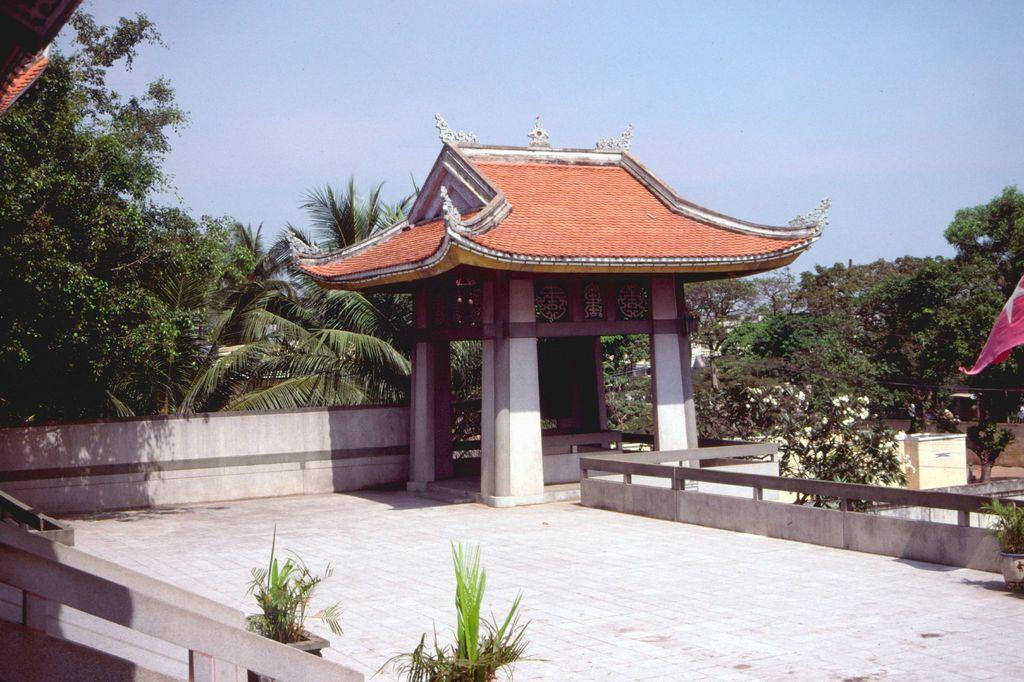What type of structure is present in the image? There is a shed in the image. What can be seen near the shed? There are potted plants in the image. What is visible in the background of the image? There are trees and the sky in the background of the image. What type of process is being carried out in the shed in the image? There is no indication of a process being carried out in the shed in the image. How many oranges are visible on the trees in the background of the image? There are no oranges visible on the trees in the background of the image. 